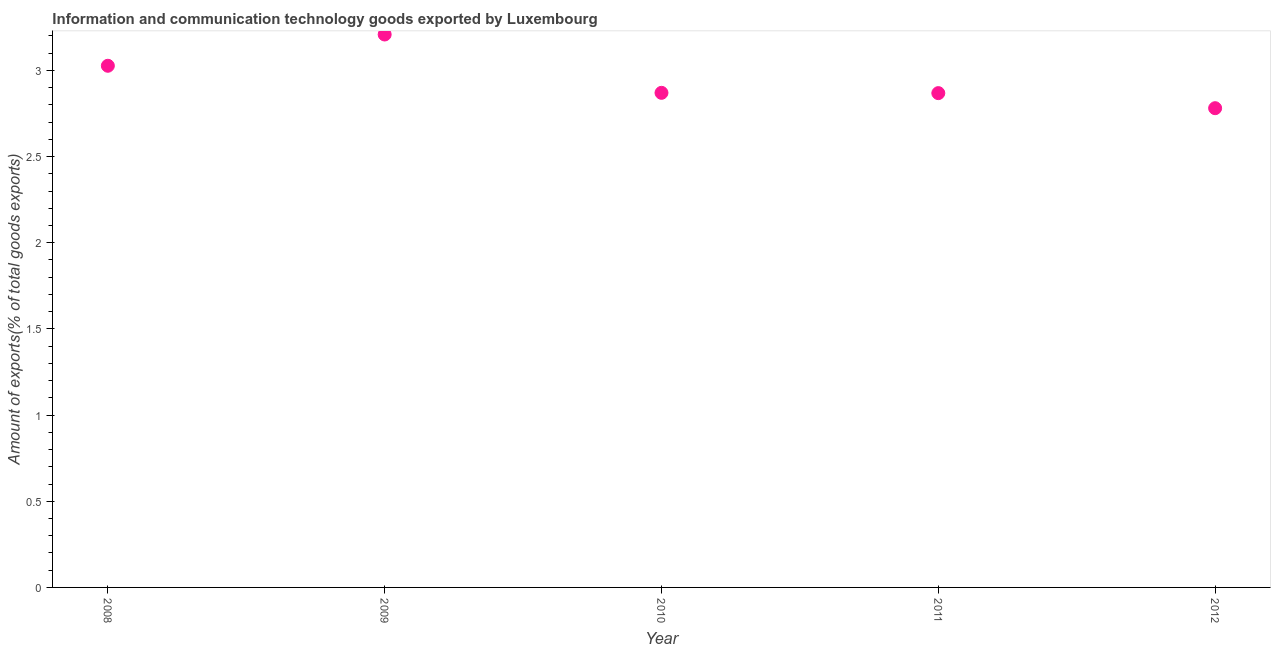What is the amount of ict goods exports in 2011?
Make the answer very short. 2.87. Across all years, what is the maximum amount of ict goods exports?
Your response must be concise. 3.21. Across all years, what is the minimum amount of ict goods exports?
Provide a short and direct response. 2.78. In which year was the amount of ict goods exports maximum?
Give a very brief answer. 2009. In which year was the amount of ict goods exports minimum?
Provide a short and direct response. 2012. What is the sum of the amount of ict goods exports?
Keep it short and to the point. 14.75. What is the difference between the amount of ict goods exports in 2008 and 2010?
Make the answer very short. 0.16. What is the average amount of ict goods exports per year?
Your answer should be compact. 2.95. What is the median amount of ict goods exports?
Make the answer very short. 2.87. In how many years, is the amount of ict goods exports greater than 3.1 %?
Provide a succinct answer. 1. Do a majority of the years between 2009 and 2012 (inclusive) have amount of ict goods exports greater than 3 %?
Give a very brief answer. No. What is the ratio of the amount of ict goods exports in 2008 to that in 2009?
Your response must be concise. 0.94. Is the amount of ict goods exports in 2011 less than that in 2012?
Ensure brevity in your answer.  No. Is the difference between the amount of ict goods exports in 2011 and 2012 greater than the difference between any two years?
Provide a short and direct response. No. What is the difference between the highest and the second highest amount of ict goods exports?
Your answer should be very brief. 0.18. Is the sum of the amount of ict goods exports in 2009 and 2011 greater than the maximum amount of ict goods exports across all years?
Give a very brief answer. Yes. What is the difference between the highest and the lowest amount of ict goods exports?
Provide a short and direct response. 0.43. In how many years, is the amount of ict goods exports greater than the average amount of ict goods exports taken over all years?
Ensure brevity in your answer.  2. Does the amount of ict goods exports monotonically increase over the years?
Provide a short and direct response. No. How many dotlines are there?
Provide a succinct answer. 1. How many years are there in the graph?
Your answer should be compact. 5. Does the graph contain grids?
Your answer should be very brief. No. What is the title of the graph?
Your answer should be compact. Information and communication technology goods exported by Luxembourg. What is the label or title of the X-axis?
Offer a very short reply. Year. What is the label or title of the Y-axis?
Provide a succinct answer. Amount of exports(% of total goods exports). What is the Amount of exports(% of total goods exports) in 2008?
Your answer should be very brief. 3.03. What is the Amount of exports(% of total goods exports) in 2009?
Make the answer very short. 3.21. What is the Amount of exports(% of total goods exports) in 2010?
Offer a very short reply. 2.87. What is the Amount of exports(% of total goods exports) in 2011?
Your answer should be compact. 2.87. What is the Amount of exports(% of total goods exports) in 2012?
Offer a terse response. 2.78. What is the difference between the Amount of exports(% of total goods exports) in 2008 and 2009?
Offer a terse response. -0.18. What is the difference between the Amount of exports(% of total goods exports) in 2008 and 2010?
Your answer should be very brief. 0.16. What is the difference between the Amount of exports(% of total goods exports) in 2008 and 2011?
Offer a very short reply. 0.16. What is the difference between the Amount of exports(% of total goods exports) in 2008 and 2012?
Make the answer very short. 0.25. What is the difference between the Amount of exports(% of total goods exports) in 2009 and 2010?
Provide a succinct answer. 0.34. What is the difference between the Amount of exports(% of total goods exports) in 2009 and 2011?
Provide a short and direct response. 0.34. What is the difference between the Amount of exports(% of total goods exports) in 2009 and 2012?
Your response must be concise. 0.43. What is the difference between the Amount of exports(% of total goods exports) in 2010 and 2011?
Provide a succinct answer. 0. What is the difference between the Amount of exports(% of total goods exports) in 2010 and 2012?
Offer a terse response. 0.09. What is the difference between the Amount of exports(% of total goods exports) in 2011 and 2012?
Your answer should be very brief. 0.09. What is the ratio of the Amount of exports(% of total goods exports) in 2008 to that in 2009?
Your answer should be very brief. 0.94. What is the ratio of the Amount of exports(% of total goods exports) in 2008 to that in 2010?
Offer a terse response. 1.05. What is the ratio of the Amount of exports(% of total goods exports) in 2008 to that in 2011?
Your response must be concise. 1.05. What is the ratio of the Amount of exports(% of total goods exports) in 2008 to that in 2012?
Give a very brief answer. 1.09. What is the ratio of the Amount of exports(% of total goods exports) in 2009 to that in 2010?
Ensure brevity in your answer.  1.12. What is the ratio of the Amount of exports(% of total goods exports) in 2009 to that in 2011?
Make the answer very short. 1.12. What is the ratio of the Amount of exports(% of total goods exports) in 2009 to that in 2012?
Offer a very short reply. 1.15. What is the ratio of the Amount of exports(% of total goods exports) in 2010 to that in 2011?
Offer a terse response. 1. What is the ratio of the Amount of exports(% of total goods exports) in 2010 to that in 2012?
Offer a terse response. 1.03. What is the ratio of the Amount of exports(% of total goods exports) in 2011 to that in 2012?
Your answer should be compact. 1.03. 